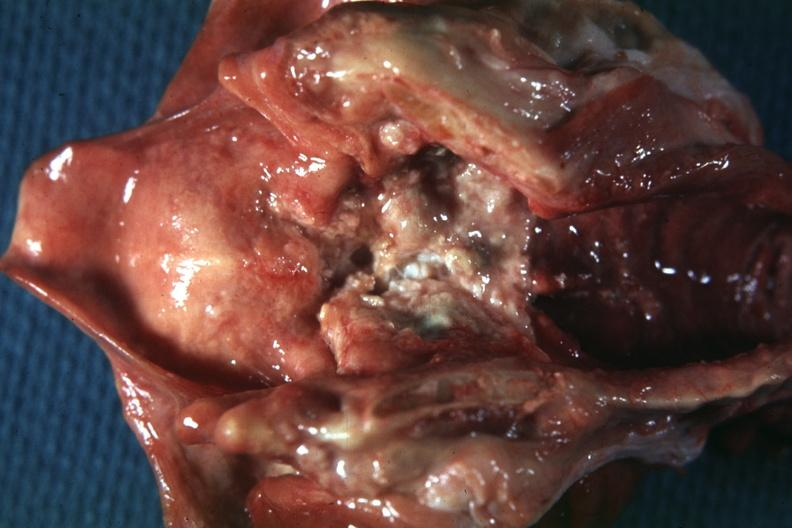s larynx present?
Answer the question using a single word or phrase. Yes 